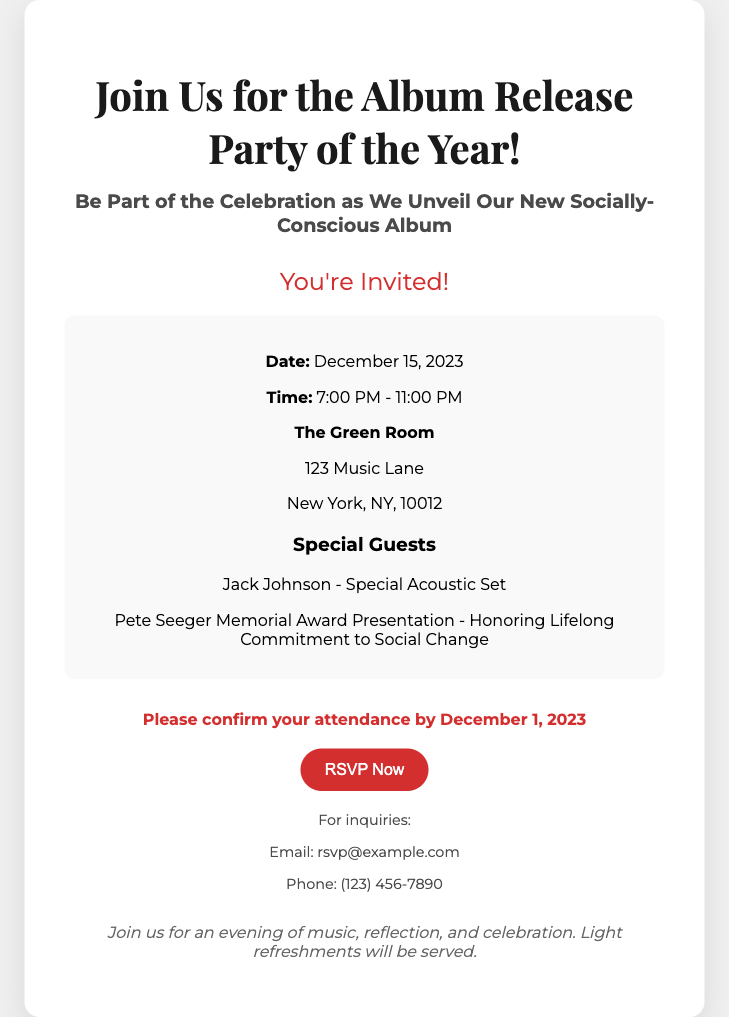what is the date of the album release party? The date provided in the document is December 15, 2023.
Answer: December 15, 2023 what time does the album release party start? The starting time mentioned in the document is 7:00 PM.
Answer: 7:00 PM where is the album release party being held? The venue listed in the document is The Green Room, which is located at 123 Music Lane.
Answer: The Green Room who is performing a special acoustic set at the party? The document specifies that Jack Johnson is the performer for the special acoustic set.
Answer: Jack Johnson by what date should attendees confirm their attendance? The RSVP deadline stated in the document is December 1, 2023.
Answer: December 1, 2023 what recognition will be presented at the event? The document mentions a Pete Seeger Memorial Award Presentation as part of the event.
Answer: Pete Seeger Memorial Award Presentation what type of refreshments will be provided? The additional info section indicates that light refreshments will be served.
Answer: Light refreshments how many hours is the event scheduled to last? The starting time is 7:00 PM and it ends at 11:00 PM, making it a total of 4 hours.
Answer: 4 hours what is the purpose of this RSVP card? The primary purpose is to confirm attendance for the album release party celebrating a new socially-conscious album.
Answer: Confirm attendance 